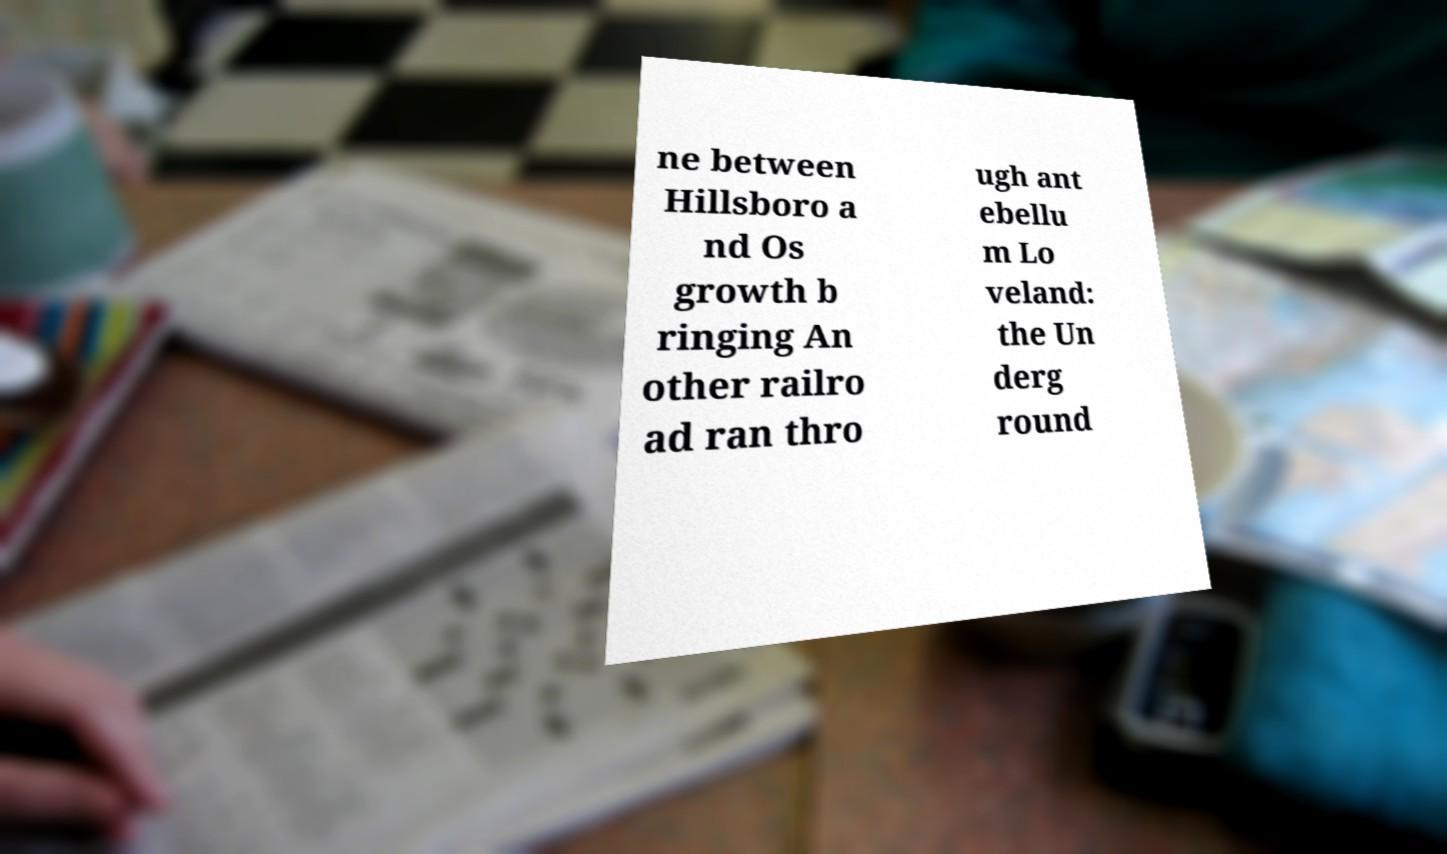Could you assist in decoding the text presented in this image and type it out clearly? ne between Hillsboro a nd Os growth b ringing An other railro ad ran thro ugh ant ebellu m Lo veland: the Un derg round 